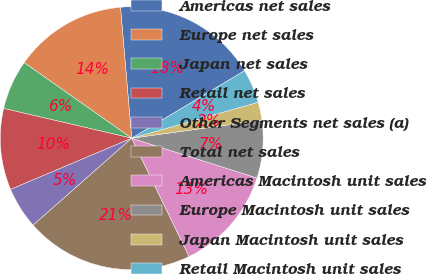Convert chart to OTSL. <chart><loc_0><loc_0><loc_500><loc_500><pie_chart><fcel>Americas net sales<fcel>Europe net sales<fcel>Japan net sales<fcel>Retail net sales<fcel>Other Segments net sales (a)<fcel>Total net sales<fcel>Americas Macintosh unit sales<fcel>Europe Macintosh unit sales<fcel>Japan Macintosh unit sales<fcel>Retail Macintosh unit sales<nl><fcel>17.78%<fcel>13.89%<fcel>6.11%<fcel>10.0%<fcel>5.14%<fcel>20.69%<fcel>12.92%<fcel>7.08%<fcel>2.22%<fcel>4.17%<nl></chart> 